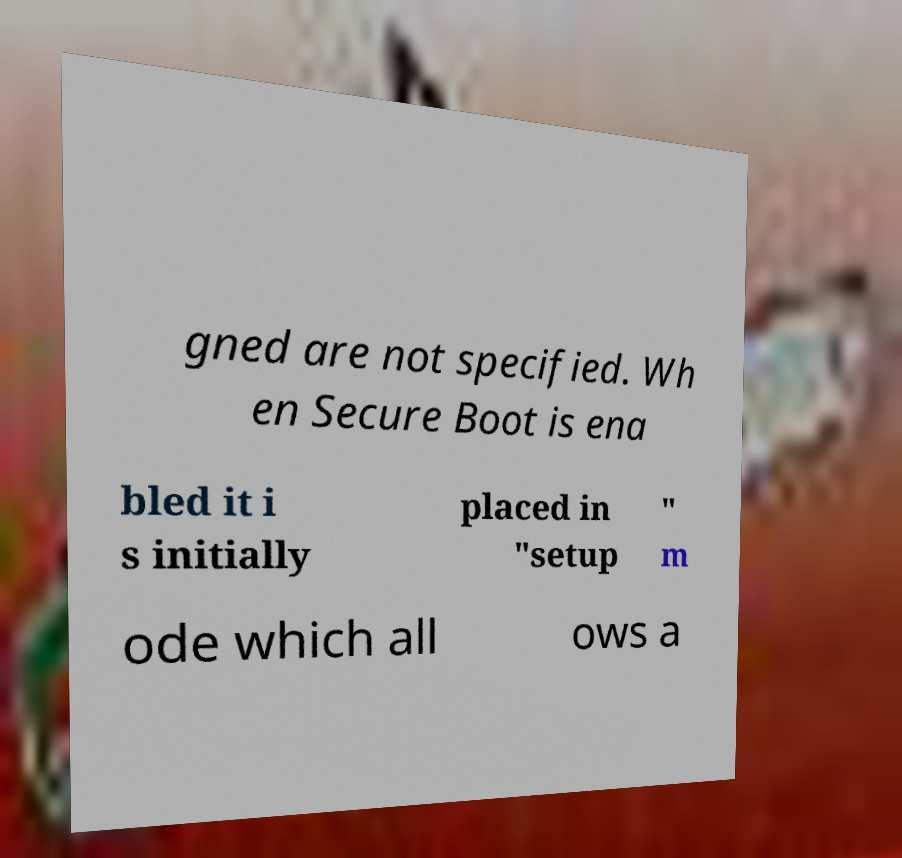Please read and relay the text visible in this image. What does it say? gned are not specified. Wh en Secure Boot is ena bled it i s initially placed in "setup " m ode which all ows a 